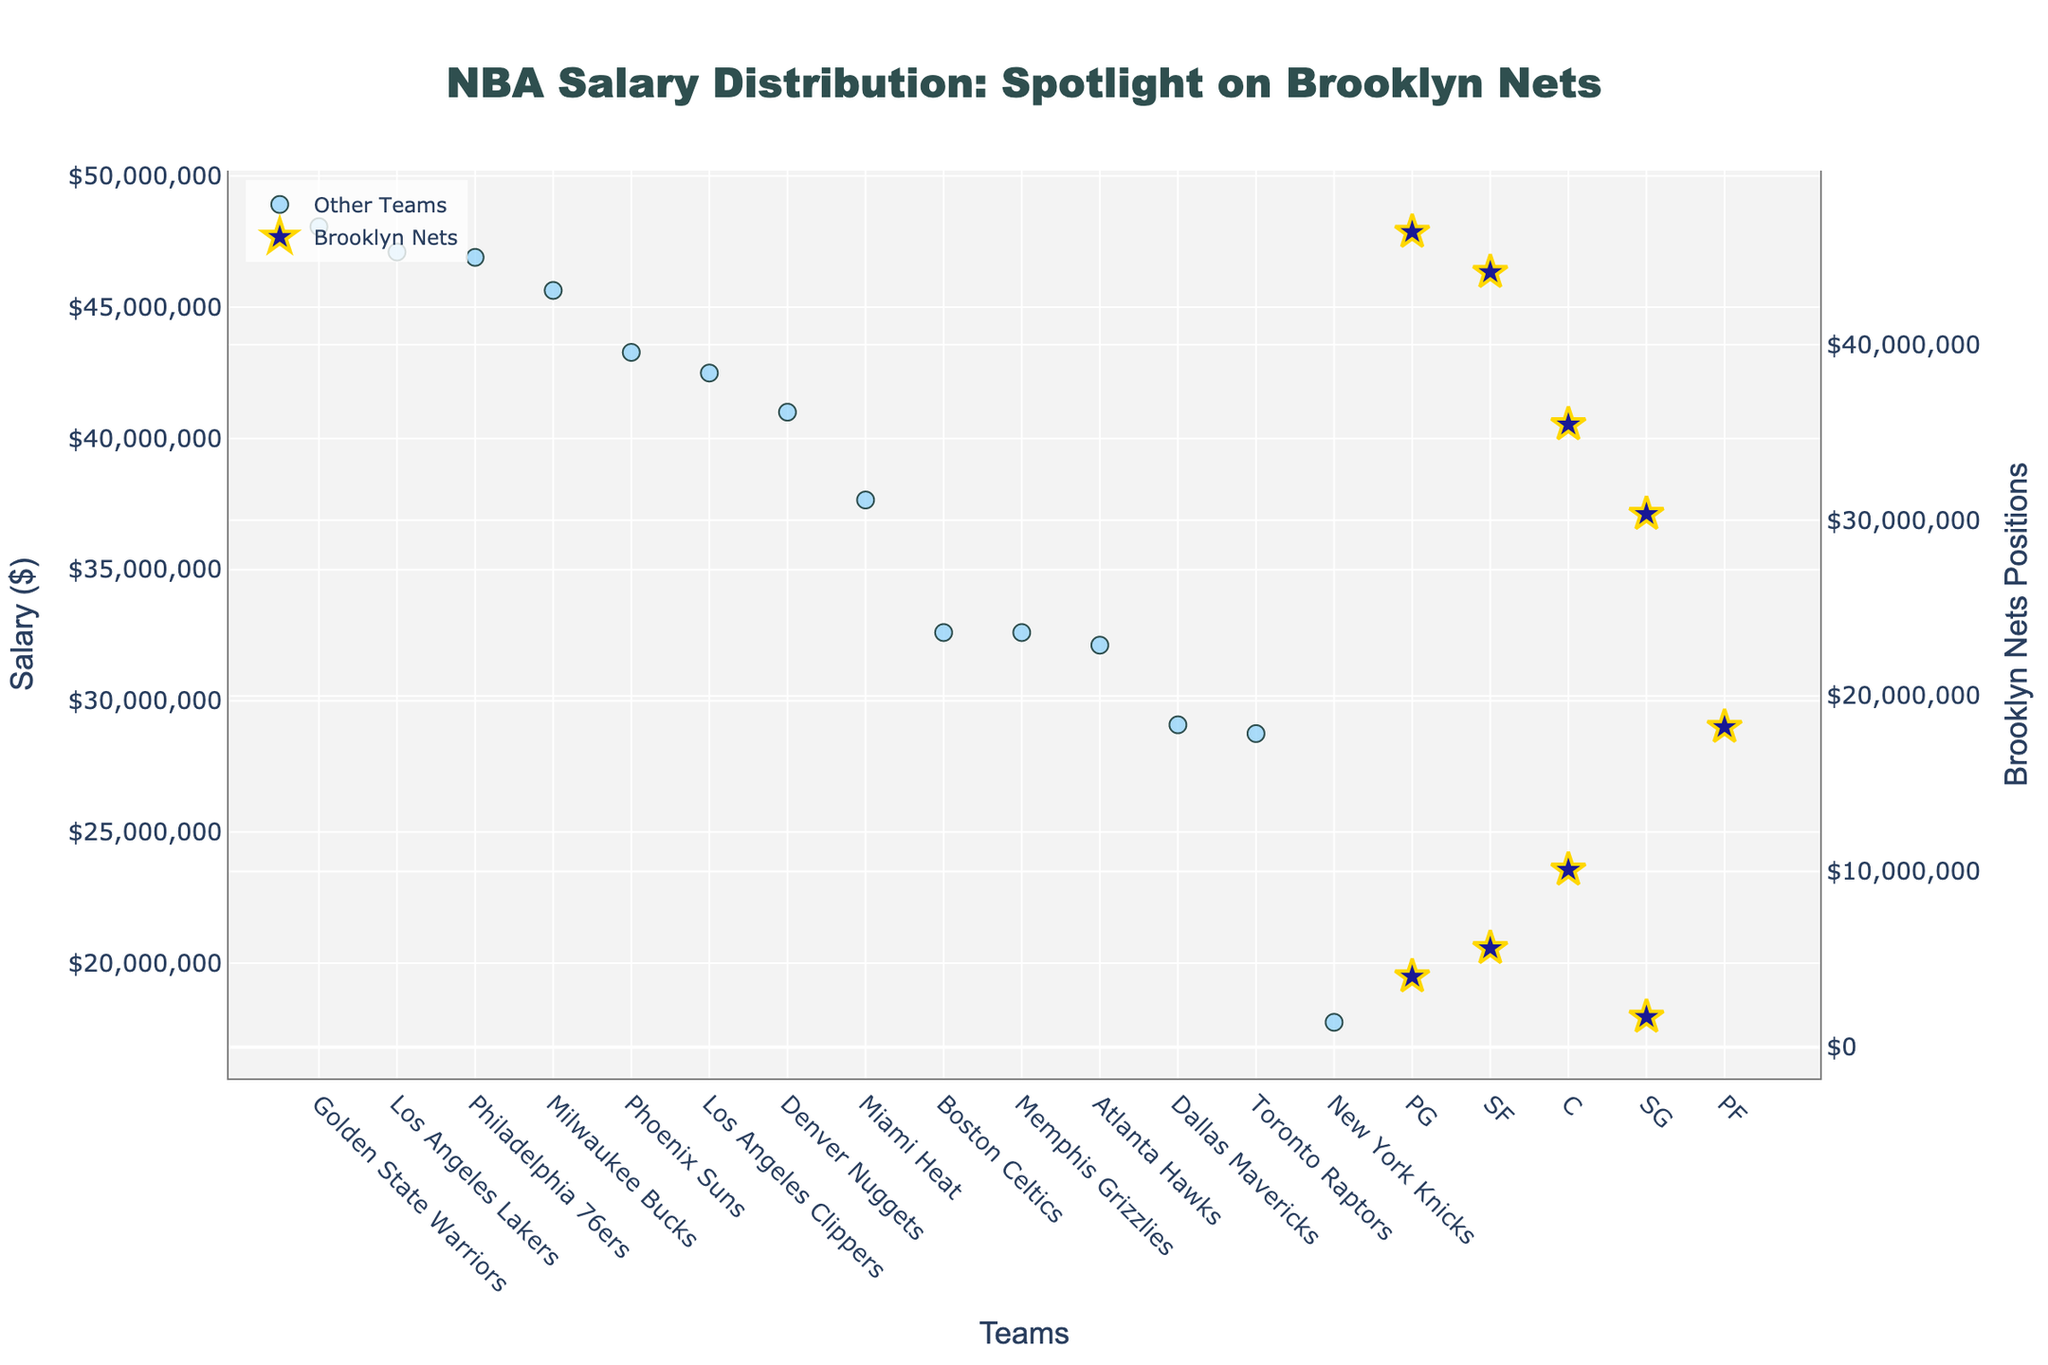What does the title of the plot indicate? The title "NBA Salary Distribution: Spotlight on Brooklyn Nets" suggests that the plot shows the distribution of salaries across NBA teams, with a special focus on the Brooklyn Nets.
Answer: It indicates an emphasis on Brooklyn Nets' salaries within the overall NBA How many Brooklyn Nets players are represented in the plot? By counting the markers under the Brooklyn Nets section, there are 9 distinct positions (PG, SF, C, SG, PF) listed for the Brooklyn Nets.
Answer: 9 players Which team has the highest salary in this data set? The team with the highest salary is the Golden State Warriors, which can be identified by finding the highest point on the plot that is labeled under "Other Teams."
Answer: Golden State Warriors What is the salary of the highest-paid Brooklyn Nets player? The highest salary for the Brooklyn Nets can be identified by finding the Brooklyn Nets' marker with the highest value. According to the plot, it is $46,407,745.
Answer: $46,407,745 Which position in the Brooklyn Nets has the lowest salary and what is it? The lowest salary for the Brooklyn Nets can be found by examining the lowest marker in the Brooklyn Nets section. The position is SG, with a salary of $1,719,843.
Answer: SG, $1,719,843 How do the salaries of Brooklyn Nets' players compare to the salaries of the other NBA teams? By visually comparing the cluster of Brooklyn Nets markers (which are larger and in dark color) to the rest of the markers (smaller and lighter in color), most of the top salaries for Brooklyn Nets are clustered lower than the top-paid players from other teams, except for a few high salaries.
Answer: Generally lower, but with some high salaries What is the approximate average salary of Brooklyn Nets players listed in the plot? To find the average salary of Brooklyn Nets players, sum their salaries ($46,407,745 + $44,119,845 + $35,450,000 + $30,351,780 + $18,226,512 + $10,096,500 + $5,633,962 + $4,017,223 + $1,719,843) and divide by the number of players (9). The sum is $196,023,410, and the average is $196,023,410 / 9 = $21,780,379.
Answer: $21,780,379 Is there a Brooklyn Nets player whose salary is below $10 million? By looking at the Brooklyn Nets markers, any point below the $10 million line on the y-axis represents such players. There are several markers representing players with salaries below this threshold.
Answer: Yes How does the salary of the most expensive Brooklyn Nets player compare to the most expensive player in the dataset? The salary of the highest-paid Brooklyn Nets player is $46,407,745, while the highest-paid player in the dataset (Golden State Warriors) has a salary of $48,070,014.
Answer: Slightly lower Which two positions hold the highest salaries for the Brooklyn Nets, and what are these salaries? The positions with the highest salaries for the Brooklyn Nets can be identified by locating the two highest markers: PG with $46,407,745 and SF with $44,119,845.
Answer: PG with $46,407,745 and SF with $44,119,845 